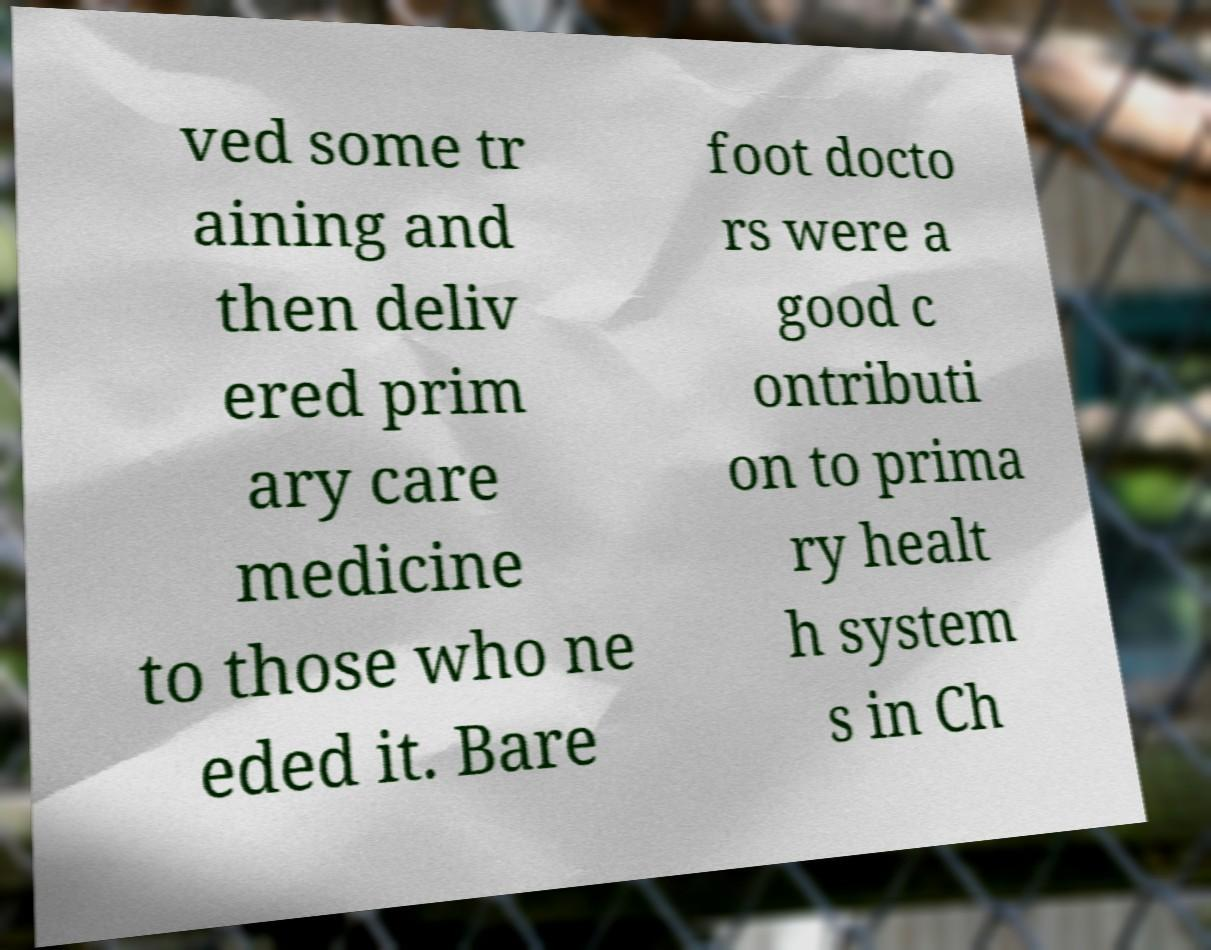For documentation purposes, I need the text within this image transcribed. Could you provide that? ved some tr aining and then deliv ered prim ary care medicine to those who ne eded it. Bare foot docto rs were a good c ontributi on to prima ry healt h system s in Ch 